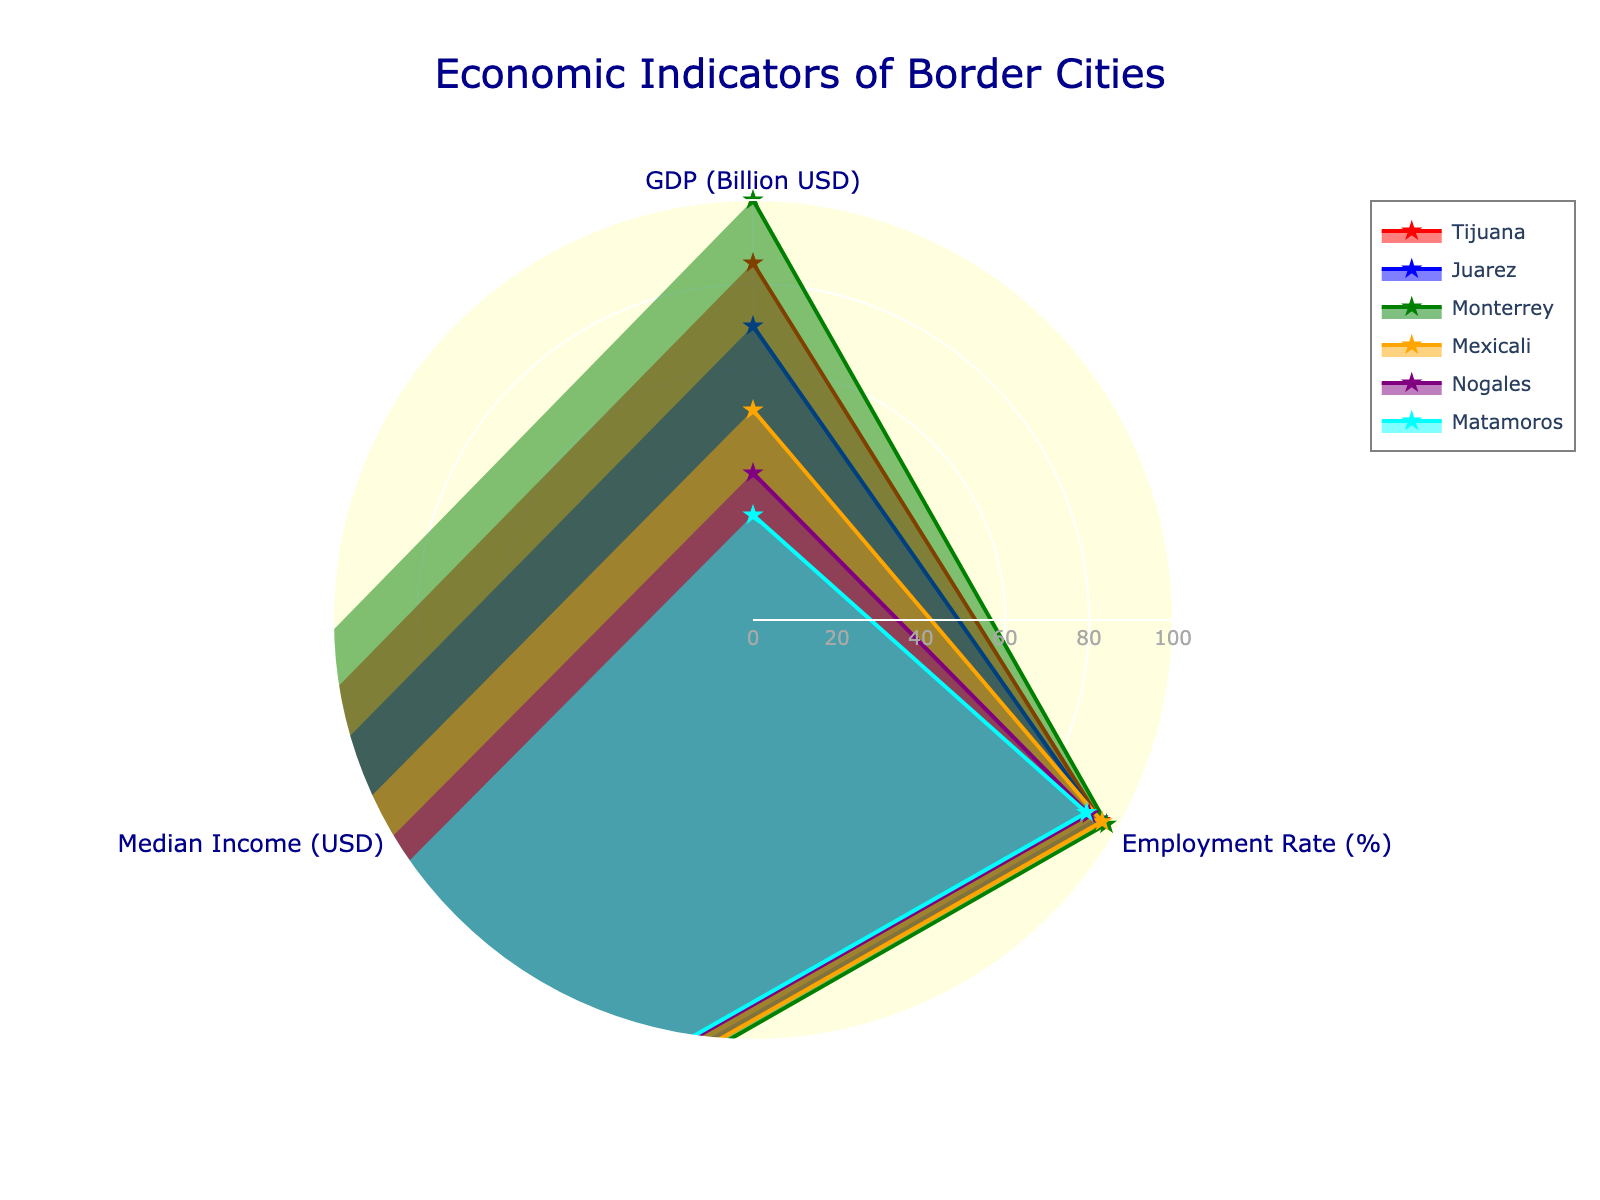What's the title of the figure? The title is located typically at the top of the figure, and it summarizes the content or subject of the figure.
Answer: Economic Indicators of Border Cities How many cities are compared in the radar chart? Count the number of unique traces (each representing a city) in the radar chart.
Answer: 6 Which city has the highest GDP? Observe the radial points on the 'GDP (Billion USD)' axis and identify the city corresponding to the highest value.
Answer: Monterrey What is the average employment rate across all cities? Sum up the employment rates of all cities (95.5 + 94.8 + 97.2 + 96.0 + 92.4 + 91.7) and divide by the number of cities (6).
Answer: 94.6% Which city has the lowest median income? Find the radial points on the 'Median Income (USD)' axis and identify the city with the lowest value.
Answer: Nogales Rank the cities by GDP from highest to lowest. Identify the values on the 'GDP (Billion USD)' axis for all cities and rank them from the highest to the lowest value.
Answer: Monterrey, Tijuana, Juarez, Mexicali, Nogales, Matamoros Which city has the smallest area on the radar chart? Visually assess the filled areas (polygons) within the radar chart and identify the one with the smallest size.
Answer: Matamoros Do any cities have an equal employment rate but different median incomes? Compare the radial points on the 'Employment Rate (%)' axis and check if any cities overlap. Then, compare their positions on the 'Median Income (USD)' axis.
Answer: No Between Juarez and Mexicali, which city has a higher median income? Compare the radial points for Juarez and Mexicali on the 'Median Income (USD)' axis.
Answer: Juarez Which city has the most balanced economic indicators across all three categories? Look for the city whose radar chart area appears the most symmetrical and evenly distributed across 'GDP', 'Employment Rate', and 'Median Income'.
Answer: Monterrey 